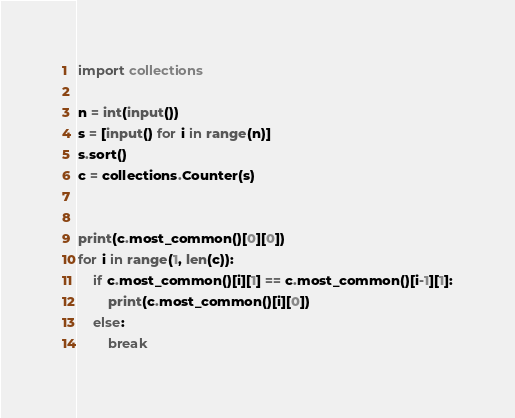Convert code to text. <code><loc_0><loc_0><loc_500><loc_500><_Python_>import collections

n = int(input())
s = [input() for i in range(n)]
s.sort()
c = collections.Counter(s)


print(c.most_common()[0][0])
for i in range(1, len(c)):
    if c.most_common()[i][1] == c.most_common()[i-1][1]:
        print(c.most_common()[i][0])
    else:
        break
</code> 